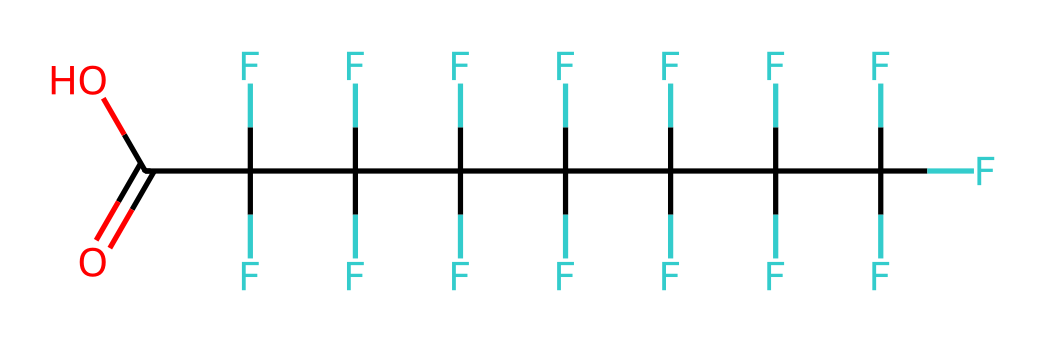What is the functional group present in this chemical? The chemical structure includes a carboxylic acid functional group, indicated by the -COOH at the end of the molecule. This group is recognized as it has a carbon atom double-bonded to an oxygen atom and single-bonded to a hydroxyl (-OH) group.
Answer: carboxylic acid How many carbon atoms are in this molecule? By examining the structure provided by the SMILES representation, it can be seen that there are eight carbon atoms in the longest chain, as denoted by 'C' in the SMILES. Each 'C' represents one carbon in the molecular structure.
Answer: eight What type of lipid does this chemical resemble? This chemical resembles a fatty acid due to the presence of a long carbon chain and a carboxylic acid functional group at one end, which is characteristic of fatty acids.
Answer: fatty acid How many fluorine atoms are attached to carbon atoms in this molecule? The molecular structure contains 17 fluorine atoms as indicated by the repetition of the fluorine (F) notation preceding the carbon atoms in the chain. Each carbon in this structure is fully fluorinated except for the last one that is part of the carboxylic acid.
Answer: seventeen What impact could this PFAS compound have on crop lipids? Due to its hydrophobic and lipophilic properties, this PFAS compound can disrupt the normal lipid metabolism in crops, potentially altering membrane structures and fatty acid profiles, which can lead to impaired growth or reduced crop yields.
Answer: disrupt lipid metabolism What is the primary reason PFAS is persistent in the environment? The strong carbon-fluorine bonds present in PFAS make them exceptionally stable and resistant to degradation, which is the main reason for their persistence in the environment, allowing them to accumulate over time.
Answer: stable and resistant 